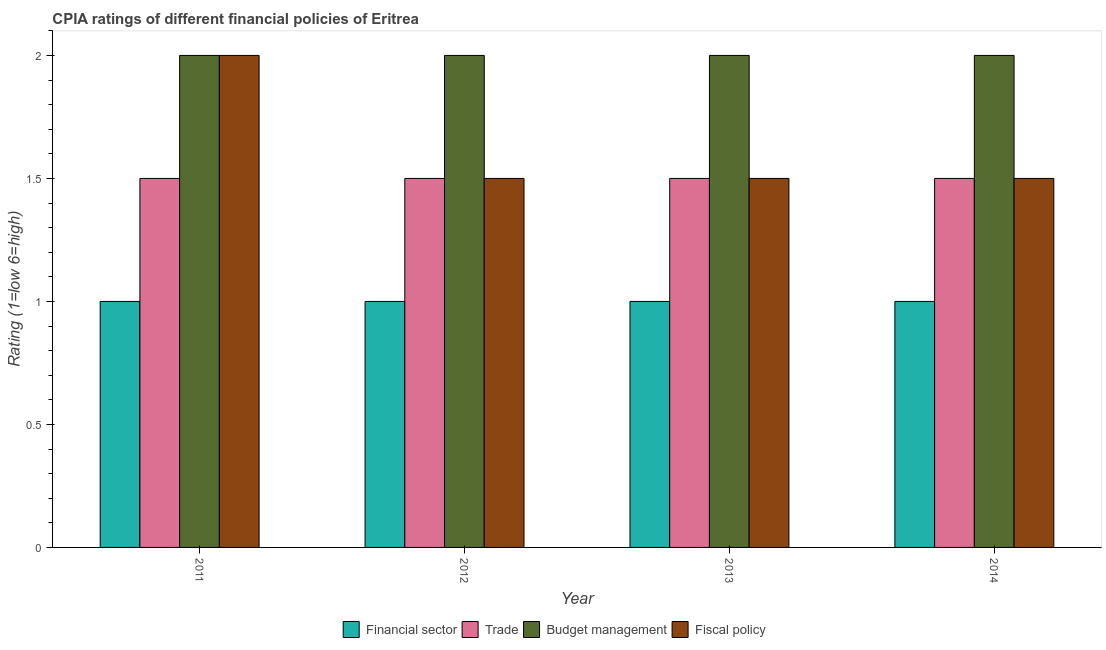How many groups of bars are there?
Make the answer very short. 4. Are the number of bars per tick equal to the number of legend labels?
Make the answer very short. Yes. Are the number of bars on each tick of the X-axis equal?
Your response must be concise. Yes. In how many cases, is the number of bars for a given year not equal to the number of legend labels?
Make the answer very short. 0. Across all years, what is the maximum cpia rating of budget management?
Ensure brevity in your answer.  2. Across all years, what is the minimum cpia rating of budget management?
Offer a terse response. 2. In which year was the cpia rating of budget management maximum?
Give a very brief answer. 2011. In which year was the cpia rating of trade minimum?
Make the answer very short. 2011. What is the difference between the cpia rating of budget management in 2012 and the cpia rating of financial sector in 2011?
Make the answer very short. 0. In how many years, is the cpia rating of trade greater than 0.2?
Make the answer very short. 4. Is the cpia rating of financial sector in 2012 less than that in 2014?
Offer a very short reply. No. Is the difference between the cpia rating of fiscal policy in 2011 and 2012 greater than the difference between the cpia rating of budget management in 2011 and 2012?
Your answer should be very brief. No. What is the difference between the highest and the second highest cpia rating of fiscal policy?
Make the answer very short. 0.5. What is the difference between the highest and the lowest cpia rating of trade?
Offer a terse response. 0. Is the sum of the cpia rating of budget management in 2011 and 2013 greater than the maximum cpia rating of fiscal policy across all years?
Provide a succinct answer. Yes. What does the 2nd bar from the left in 2012 represents?
Make the answer very short. Trade. What does the 4th bar from the right in 2013 represents?
Your response must be concise. Financial sector. Is it the case that in every year, the sum of the cpia rating of financial sector and cpia rating of trade is greater than the cpia rating of budget management?
Offer a terse response. Yes. What is the difference between two consecutive major ticks on the Y-axis?
Ensure brevity in your answer.  0.5. How many legend labels are there?
Offer a terse response. 4. What is the title of the graph?
Provide a succinct answer. CPIA ratings of different financial policies of Eritrea. What is the Rating (1=low 6=high) in Trade in 2011?
Provide a short and direct response. 1.5. What is the Rating (1=low 6=high) of Financial sector in 2012?
Offer a terse response. 1. What is the Rating (1=low 6=high) in Budget management in 2013?
Your answer should be very brief. 2. What is the Rating (1=low 6=high) in Trade in 2014?
Your answer should be compact. 1.5. What is the Rating (1=low 6=high) of Fiscal policy in 2014?
Provide a succinct answer. 1.5. Across all years, what is the maximum Rating (1=low 6=high) in Financial sector?
Provide a succinct answer. 1. Across all years, what is the maximum Rating (1=low 6=high) in Trade?
Your answer should be very brief. 1.5. Across all years, what is the maximum Rating (1=low 6=high) in Budget management?
Make the answer very short. 2. Across all years, what is the minimum Rating (1=low 6=high) of Financial sector?
Your answer should be very brief. 1. Across all years, what is the minimum Rating (1=low 6=high) of Budget management?
Your answer should be very brief. 2. Across all years, what is the minimum Rating (1=low 6=high) of Fiscal policy?
Make the answer very short. 1.5. What is the total Rating (1=low 6=high) in Fiscal policy in the graph?
Your response must be concise. 6.5. What is the difference between the Rating (1=low 6=high) in Financial sector in 2011 and that in 2012?
Offer a very short reply. 0. What is the difference between the Rating (1=low 6=high) in Trade in 2011 and that in 2012?
Keep it short and to the point. 0. What is the difference between the Rating (1=low 6=high) of Budget management in 2011 and that in 2012?
Offer a very short reply. 0. What is the difference between the Rating (1=low 6=high) of Financial sector in 2011 and that in 2013?
Give a very brief answer. 0. What is the difference between the Rating (1=low 6=high) in Trade in 2011 and that in 2013?
Keep it short and to the point. 0. What is the difference between the Rating (1=low 6=high) of Budget management in 2011 and that in 2013?
Provide a succinct answer. 0. What is the difference between the Rating (1=low 6=high) of Trade in 2011 and that in 2014?
Make the answer very short. 0. What is the difference between the Rating (1=low 6=high) in Budget management in 2011 and that in 2014?
Keep it short and to the point. 0. What is the difference between the Rating (1=low 6=high) of Trade in 2012 and that in 2013?
Offer a very short reply. 0. What is the difference between the Rating (1=low 6=high) of Budget management in 2012 and that in 2013?
Provide a succinct answer. 0. What is the difference between the Rating (1=low 6=high) of Fiscal policy in 2012 and that in 2013?
Make the answer very short. 0. What is the difference between the Rating (1=low 6=high) of Budget management in 2012 and that in 2014?
Keep it short and to the point. 0. What is the difference between the Rating (1=low 6=high) in Fiscal policy in 2012 and that in 2014?
Your answer should be compact. 0. What is the difference between the Rating (1=low 6=high) in Financial sector in 2013 and that in 2014?
Ensure brevity in your answer.  0. What is the difference between the Rating (1=low 6=high) in Fiscal policy in 2013 and that in 2014?
Offer a very short reply. 0. What is the difference between the Rating (1=low 6=high) in Financial sector in 2011 and the Rating (1=low 6=high) in Trade in 2012?
Offer a terse response. -0.5. What is the difference between the Rating (1=low 6=high) in Financial sector in 2011 and the Rating (1=low 6=high) in Trade in 2013?
Your answer should be compact. -0.5. What is the difference between the Rating (1=low 6=high) of Trade in 2011 and the Rating (1=low 6=high) of Fiscal policy in 2013?
Offer a terse response. 0. What is the difference between the Rating (1=low 6=high) in Budget management in 2011 and the Rating (1=low 6=high) in Fiscal policy in 2013?
Give a very brief answer. 0.5. What is the difference between the Rating (1=low 6=high) of Trade in 2011 and the Rating (1=low 6=high) of Budget management in 2014?
Your answer should be very brief. -0.5. What is the difference between the Rating (1=low 6=high) of Trade in 2011 and the Rating (1=low 6=high) of Fiscal policy in 2014?
Provide a short and direct response. 0. What is the difference between the Rating (1=low 6=high) in Financial sector in 2012 and the Rating (1=low 6=high) in Trade in 2013?
Give a very brief answer. -0.5. What is the difference between the Rating (1=low 6=high) in Financial sector in 2012 and the Rating (1=low 6=high) in Budget management in 2014?
Make the answer very short. -1. What is the difference between the Rating (1=low 6=high) of Trade in 2012 and the Rating (1=low 6=high) of Fiscal policy in 2014?
Your answer should be very brief. 0. What is the difference between the Rating (1=low 6=high) of Budget management in 2012 and the Rating (1=low 6=high) of Fiscal policy in 2014?
Ensure brevity in your answer.  0.5. What is the difference between the Rating (1=low 6=high) of Trade in 2013 and the Rating (1=low 6=high) of Budget management in 2014?
Your answer should be compact. -0.5. What is the difference between the Rating (1=low 6=high) in Budget management in 2013 and the Rating (1=low 6=high) in Fiscal policy in 2014?
Provide a short and direct response. 0.5. What is the average Rating (1=low 6=high) in Fiscal policy per year?
Offer a very short reply. 1.62. In the year 2011, what is the difference between the Rating (1=low 6=high) of Budget management and Rating (1=low 6=high) of Fiscal policy?
Keep it short and to the point. 0. In the year 2012, what is the difference between the Rating (1=low 6=high) in Financial sector and Rating (1=low 6=high) in Trade?
Your answer should be compact. -0.5. In the year 2012, what is the difference between the Rating (1=low 6=high) in Trade and Rating (1=low 6=high) in Budget management?
Your answer should be compact. -0.5. In the year 2012, what is the difference between the Rating (1=low 6=high) of Budget management and Rating (1=low 6=high) of Fiscal policy?
Your response must be concise. 0.5. In the year 2013, what is the difference between the Rating (1=low 6=high) in Financial sector and Rating (1=low 6=high) in Budget management?
Your response must be concise. -1. In the year 2013, what is the difference between the Rating (1=low 6=high) of Financial sector and Rating (1=low 6=high) of Fiscal policy?
Keep it short and to the point. -0.5. In the year 2013, what is the difference between the Rating (1=low 6=high) in Trade and Rating (1=low 6=high) in Fiscal policy?
Provide a short and direct response. 0. In the year 2013, what is the difference between the Rating (1=low 6=high) in Budget management and Rating (1=low 6=high) in Fiscal policy?
Make the answer very short. 0.5. In the year 2014, what is the difference between the Rating (1=low 6=high) in Financial sector and Rating (1=low 6=high) in Budget management?
Keep it short and to the point. -1. In the year 2014, what is the difference between the Rating (1=low 6=high) in Financial sector and Rating (1=low 6=high) in Fiscal policy?
Ensure brevity in your answer.  -0.5. In the year 2014, what is the difference between the Rating (1=low 6=high) in Trade and Rating (1=low 6=high) in Fiscal policy?
Provide a short and direct response. 0. In the year 2014, what is the difference between the Rating (1=low 6=high) in Budget management and Rating (1=low 6=high) in Fiscal policy?
Your response must be concise. 0.5. What is the ratio of the Rating (1=low 6=high) of Fiscal policy in 2011 to that in 2012?
Make the answer very short. 1.33. What is the ratio of the Rating (1=low 6=high) in Fiscal policy in 2011 to that in 2013?
Keep it short and to the point. 1.33. What is the ratio of the Rating (1=low 6=high) of Financial sector in 2011 to that in 2014?
Your answer should be very brief. 1. What is the ratio of the Rating (1=low 6=high) in Budget management in 2011 to that in 2014?
Offer a very short reply. 1. What is the ratio of the Rating (1=low 6=high) of Fiscal policy in 2011 to that in 2014?
Your answer should be very brief. 1.33. What is the ratio of the Rating (1=low 6=high) of Trade in 2012 to that in 2013?
Give a very brief answer. 1. What is the ratio of the Rating (1=low 6=high) in Budget management in 2012 to that in 2013?
Make the answer very short. 1. What is the ratio of the Rating (1=low 6=high) of Budget management in 2012 to that in 2014?
Your response must be concise. 1. What is the ratio of the Rating (1=low 6=high) in Fiscal policy in 2012 to that in 2014?
Offer a very short reply. 1. What is the ratio of the Rating (1=low 6=high) in Trade in 2013 to that in 2014?
Offer a very short reply. 1. What is the ratio of the Rating (1=low 6=high) in Budget management in 2013 to that in 2014?
Your response must be concise. 1. What is the ratio of the Rating (1=low 6=high) of Fiscal policy in 2013 to that in 2014?
Ensure brevity in your answer.  1. What is the difference between the highest and the second highest Rating (1=low 6=high) in Trade?
Give a very brief answer. 0. What is the difference between the highest and the second highest Rating (1=low 6=high) of Fiscal policy?
Your response must be concise. 0.5. What is the difference between the highest and the lowest Rating (1=low 6=high) of Trade?
Your answer should be compact. 0. What is the difference between the highest and the lowest Rating (1=low 6=high) of Budget management?
Give a very brief answer. 0. 